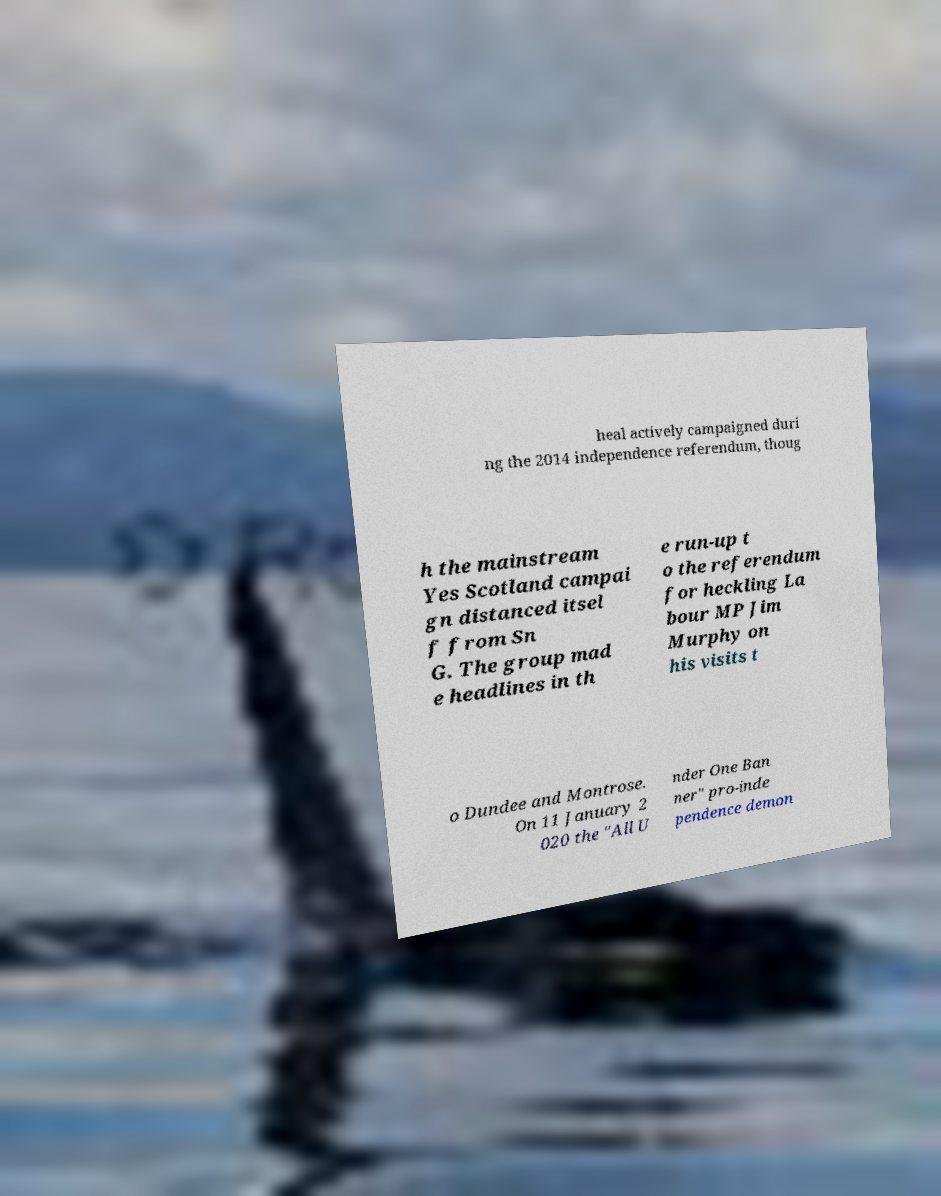Could you assist in decoding the text presented in this image and type it out clearly? heal actively campaigned duri ng the 2014 independence referendum, thoug h the mainstream Yes Scotland campai gn distanced itsel f from Sn G. The group mad e headlines in th e run-up t o the referendum for heckling La bour MP Jim Murphy on his visits t o Dundee and Montrose. On 11 January 2 020 the "All U nder One Ban ner" pro-inde pendence demon 